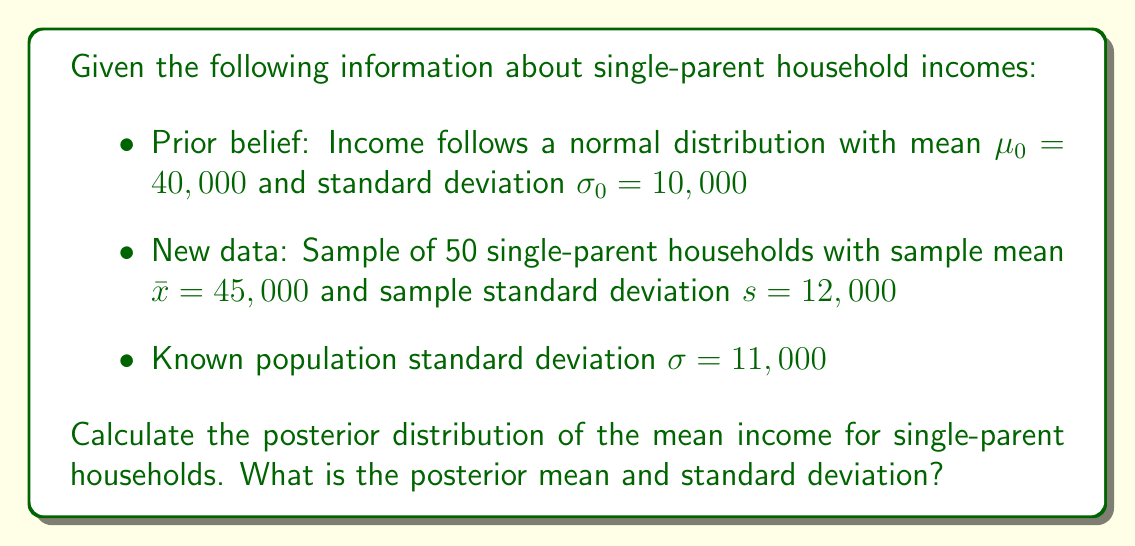Can you answer this question? To solve this problem, we'll use Bayesian updating for a normal distribution with known variance. The steps are as follows:

1) The prior distribution is $N(\mu_0, \sigma_0^2)$, where $\mu_0 = 40,000$ and $\sigma_0 = 10,000$.

2) The likelihood is based on the sample data, which has a mean of $\bar{x} = 45,000$ and a sample size of $n = 50$. The known population standard deviation is $\sigma = 11,000$.

3) The posterior distribution will also be normal, with parameters that we can calculate using these formulas:

   $$\mu_n = \frac{\frac{\mu_0}{\sigma_0^2} + \frac{n\bar{x}}{\sigma^2}}{\frac{1}{\sigma_0^2} + \frac{n}{\sigma^2}}$$

   $$\sigma_n^2 = \frac{1}{\frac{1}{\sigma_0^2} + \frac{n}{\sigma^2}}$$

4) Let's calculate $\sigma_n^2$ first:

   $$\sigma_n^2 = \frac{1}{\frac{1}{10,000^2} + \frac{50}{11,000^2}} = \frac{1}{1 \times 10^{-8} + 4.13 \times 10^{-7}} = 2,358,491$$

   So, $\sigma_n = \sqrt{2,358,491} \approx 1,536$

5) Now for $\mu_n$:

   $$\mu_n = \frac{\frac{40,000}{10,000^2} + \frac{50 \times 45,000}{11,000^2}}{\frac{1}{10,000^2} + \frac{50}{11,000^2}} = \frac{4 \times 10^{-4} + 1.86 \times 10^{-2}}{1 \times 10^{-8} + 4.13 \times 10^{-7}} = 44,858$$

Therefore, the posterior distribution is $N(44,858, 1,536^2)$.
Answer: The posterior distribution of the mean income for single-parent households is normal with mean $\mu_n = 44,858$ and standard deviation $\sigma_n = 1,536$. 